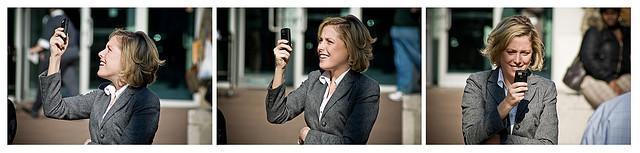How many people are there?
Give a very brief answer. 5. 